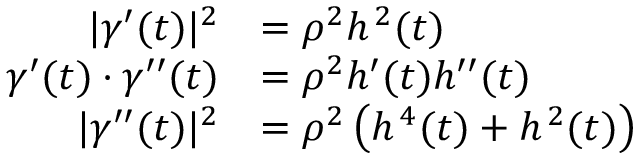<formula> <loc_0><loc_0><loc_500><loc_500>{ \begin{array} { r l } { | { \gamma } ^ { \prime } ( t ) | ^ { 2 } } & { = \rho ^ { 2 } h ^ { \, 2 } ( t ) } \\ { { \gamma } ^ { \prime } ( t ) \cdot { \gamma } ^ { \prime \prime } ( t ) } & { = \rho ^ { 2 } h ^ { \prime } ( t ) h ^ { \prime \prime } ( t ) } \\ { | { \gamma } ^ { \prime \prime } ( t ) | ^ { 2 } } & { = \rho ^ { 2 } \left ( h ^ { \, 4 } ( t ) + h ^ { \, 2 } ( t ) \right ) } \end{array} }</formula> 